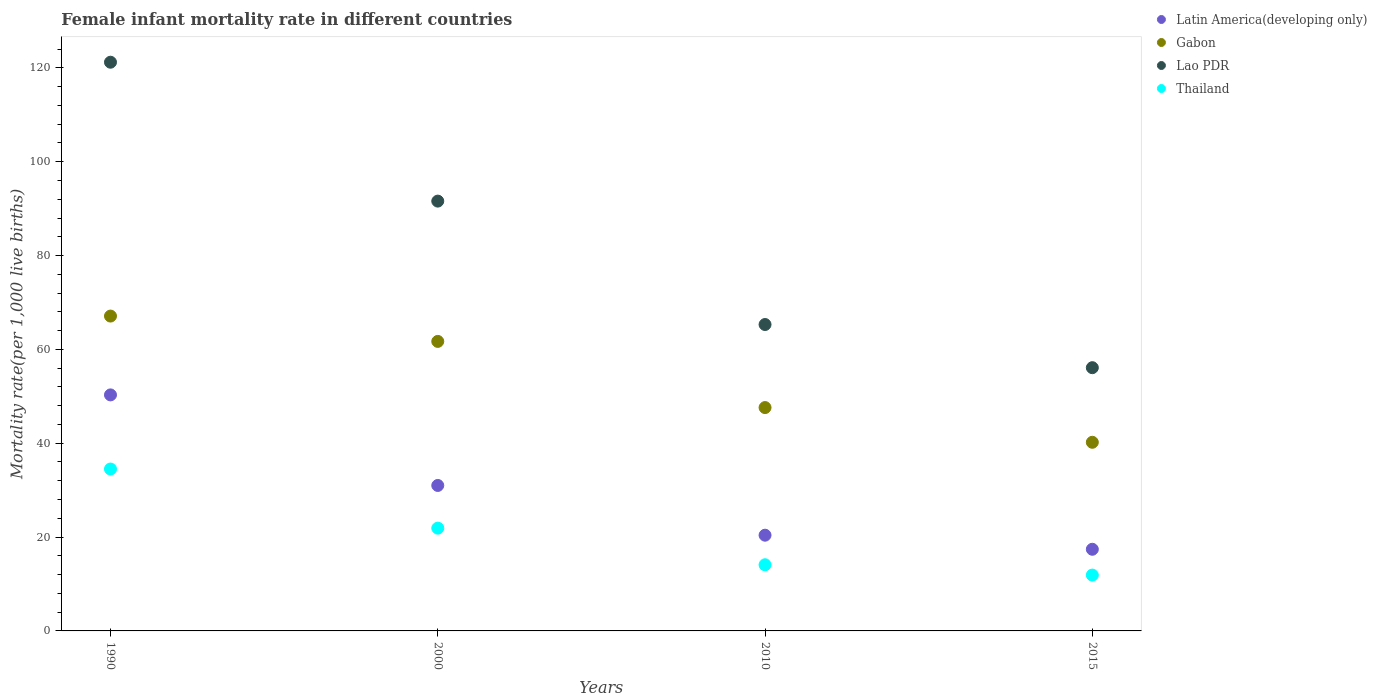How many different coloured dotlines are there?
Make the answer very short. 4. Is the number of dotlines equal to the number of legend labels?
Provide a succinct answer. Yes. Across all years, what is the maximum female infant mortality rate in Lao PDR?
Offer a very short reply. 121.2. Across all years, what is the minimum female infant mortality rate in Gabon?
Ensure brevity in your answer.  40.2. In which year was the female infant mortality rate in Latin America(developing only) maximum?
Ensure brevity in your answer.  1990. In which year was the female infant mortality rate in Lao PDR minimum?
Provide a succinct answer. 2015. What is the total female infant mortality rate in Gabon in the graph?
Make the answer very short. 216.6. What is the difference between the female infant mortality rate in Lao PDR in 2000 and that in 2015?
Your response must be concise. 35.5. What is the difference between the female infant mortality rate in Thailand in 2015 and the female infant mortality rate in Lao PDR in 1990?
Give a very brief answer. -109.3. What is the average female infant mortality rate in Thailand per year?
Give a very brief answer. 20.6. In the year 2010, what is the difference between the female infant mortality rate in Latin America(developing only) and female infant mortality rate in Thailand?
Offer a terse response. 6.3. What is the ratio of the female infant mortality rate in Latin America(developing only) in 2010 to that in 2015?
Offer a very short reply. 1.17. Is the female infant mortality rate in Lao PDR in 2000 less than that in 2010?
Ensure brevity in your answer.  No. Is the difference between the female infant mortality rate in Latin America(developing only) in 1990 and 2000 greater than the difference between the female infant mortality rate in Thailand in 1990 and 2000?
Ensure brevity in your answer.  Yes. What is the difference between the highest and the second highest female infant mortality rate in Thailand?
Keep it short and to the point. 12.6. What is the difference between the highest and the lowest female infant mortality rate in Thailand?
Offer a very short reply. 22.6. Is it the case that in every year, the sum of the female infant mortality rate in Gabon and female infant mortality rate in Latin America(developing only)  is greater than the female infant mortality rate in Thailand?
Your answer should be compact. Yes. Does the female infant mortality rate in Lao PDR monotonically increase over the years?
Give a very brief answer. No. Is the female infant mortality rate in Lao PDR strictly less than the female infant mortality rate in Gabon over the years?
Your answer should be compact. No. Are the values on the major ticks of Y-axis written in scientific E-notation?
Give a very brief answer. No. Does the graph contain grids?
Your answer should be very brief. No. Where does the legend appear in the graph?
Provide a short and direct response. Top right. How many legend labels are there?
Your answer should be compact. 4. What is the title of the graph?
Make the answer very short. Female infant mortality rate in different countries. What is the label or title of the Y-axis?
Your answer should be compact. Mortality rate(per 1,0 live births). What is the Mortality rate(per 1,000 live births) of Latin America(developing only) in 1990?
Keep it short and to the point. 50.3. What is the Mortality rate(per 1,000 live births) in Gabon in 1990?
Offer a very short reply. 67.1. What is the Mortality rate(per 1,000 live births) in Lao PDR in 1990?
Your response must be concise. 121.2. What is the Mortality rate(per 1,000 live births) of Thailand in 1990?
Your answer should be very brief. 34.5. What is the Mortality rate(per 1,000 live births) in Latin America(developing only) in 2000?
Your answer should be compact. 31. What is the Mortality rate(per 1,000 live births) of Gabon in 2000?
Keep it short and to the point. 61.7. What is the Mortality rate(per 1,000 live births) in Lao PDR in 2000?
Give a very brief answer. 91.6. What is the Mortality rate(per 1,000 live births) of Thailand in 2000?
Keep it short and to the point. 21.9. What is the Mortality rate(per 1,000 live births) in Latin America(developing only) in 2010?
Keep it short and to the point. 20.4. What is the Mortality rate(per 1,000 live births) in Gabon in 2010?
Ensure brevity in your answer.  47.6. What is the Mortality rate(per 1,000 live births) of Lao PDR in 2010?
Make the answer very short. 65.3. What is the Mortality rate(per 1,000 live births) of Gabon in 2015?
Your response must be concise. 40.2. What is the Mortality rate(per 1,000 live births) of Lao PDR in 2015?
Keep it short and to the point. 56.1. What is the Mortality rate(per 1,000 live births) in Thailand in 2015?
Offer a very short reply. 11.9. Across all years, what is the maximum Mortality rate(per 1,000 live births) in Latin America(developing only)?
Offer a very short reply. 50.3. Across all years, what is the maximum Mortality rate(per 1,000 live births) in Gabon?
Your response must be concise. 67.1. Across all years, what is the maximum Mortality rate(per 1,000 live births) of Lao PDR?
Your answer should be compact. 121.2. Across all years, what is the maximum Mortality rate(per 1,000 live births) in Thailand?
Provide a succinct answer. 34.5. Across all years, what is the minimum Mortality rate(per 1,000 live births) in Gabon?
Offer a very short reply. 40.2. Across all years, what is the minimum Mortality rate(per 1,000 live births) in Lao PDR?
Provide a succinct answer. 56.1. What is the total Mortality rate(per 1,000 live births) of Latin America(developing only) in the graph?
Ensure brevity in your answer.  119.1. What is the total Mortality rate(per 1,000 live births) in Gabon in the graph?
Give a very brief answer. 216.6. What is the total Mortality rate(per 1,000 live births) in Lao PDR in the graph?
Give a very brief answer. 334.2. What is the total Mortality rate(per 1,000 live births) of Thailand in the graph?
Your answer should be very brief. 82.4. What is the difference between the Mortality rate(per 1,000 live births) of Latin America(developing only) in 1990 and that in 2000?
Provide a short and direct response. 19.3. What is the difference between the Mortality rate(per 1,000 live births) in Lao PDR in 1990 and that in 2000?
Give a very brief answer. 29.6. What is the difference between the Mortality rate(per 1,000 live births) of Thailand in 1990 and that in 2000?
Offer a terse response. 12.6. What is the difference between the Mortality rate(per 1,000 live births) of Latin America(developing only) in 1990 and that in 2010?
Offer a terse response. 29.9. What is the difference between the Mortality rate(per 1,000 live births) in Lao PDR in 1990 and that in 2010?
Your answer should be compact. 55.9. What is the difference between the Mortality rate(per 1,000 live births) in Thailand in 1990 and that in 2010?
Offer a very short reply. 20.4. What is the difference between the Mortality rate(per 1,000 live births) in Latin America(developing only) in 1990 and that in 2015?
Keep it short and to the point. 32.9. What is the difference between the Mortality rate(per 1,000 live births) in Gabon in 1990 and that in 2015?
Ensure brevity in your answer.  26.9. What is the difference between the Mortality rate(per 1,000 live births) in Lao PDR in 1990 and that in 2015?
Provide a short and direct response. 65.1. What is the difference between the Mortality rate(per 1,000 live births) of Thailand in 1990 and that in 2015?
Your answer should be compact. 22.6. What is the difference between the Mortality rate(per 1,000 live births) of Latin America(developing only) in 2000 and that in 2010?
Provide a succinct answer. 10.6. What is the difference between the Mortality rate(per 1,000 live births) of Gabon in 2000 and that in 2010?
Your response must be concise. 14.1. What is the difference between the Mortality rate(per 1,000 live births) in Lao PDR in 2000 and that in 2010?
Your answer should be very brief. 26.3. What is the difference between the Mortality rate(per 1,000 live births) in Gabon in 2000 and that in 2015?
Your answer should be very brief. 21.5. What is the difference between the Mortality rate(per 1,000 live births) of Lao PDR in 2000 and that in 2015?
Ensure brevity in your answer.  35.5. What is the difference between the Mortality rate(per 1,000 live births) in Lao PDR in 2010 and that in 2015?
Provide a short and direct response. 9.2. What is the difference between the Mortality rate(per 1,000 live births) of Thailand in 2010 and that in 2015?
Offer a terse response. 2.2. What is the difference between the Mortality rate(per 1,000 live births) of Latin America(developing only) in 1990 and the Mortality rate(per 1,000 live births) of Gabon in 2000?
Offer a very short reply. -11.4. What is the difference between the Mortality rate(per 1,000 live births) in Latin America(developing only) in 1990 and the Mortality rate(per 1,000 live births) in Lao PDR in 2000?
Your answer should be very brief. -41.3. What is the difference between the Mortality rate(per 1,000 live births) in Latin America(developing only) in 1990 and the Mortality rate(per 1,000 live births) in Thailand in 2000?
Give a very brief answer. 28.4. What is the difference between the Mortality rate(per 1,000 live births) in Gabon in 1990 and the Mortality rate(per 1,000 live births) in Lao PDR in 2000?
Provide a short and direct response. -24.5. What is the difference between the Mortality rate(per 1,000 live births) in Gabon in 1990 and the Mortality rate(per 1,000 live births) in Thailand in 2000?
Make the answer very short. 45.2. What is the difference between the Mortality rate(per 1,000 live births) of Lao PDR in 1990 and the Mortality rate(per 1,000 live births) of Thailand in 2000?
Give a very brief answer. 99.3. What is the difference between the Mortality rate(per 1,000 live births) in Latin America(developing only) in 1990 and the Mortality rate(per 1,000 live births) in Gabon in 2010?
Your answer should be compact. 2.7. What is the difference between the Mortality rate(per 1,000 live births) in Latin America(developing only) in 1990 and the Mortality rate(per 1,000 live births) in Lao PDR in 2010?
Your response must be concise. -15. What is the difference between the Mortality rate(per 1,000 live births) of Latin America(developing only) in 1990 and the Mortality rate(per 1,000 live births) of Thailand in 2010?
Your response must be concise. 36.2. What is the difference between the Mortality rate(per 1,000 live births) in Gabon in 1990 and the Mortality rate(per 1,000 live births) in Lao PDR in 2010?
Provide a short and direct response. 1.8. What is the difference between the Mortality rate(per 1,000 live births) of Gabon in 1990 and the Mortality rate(per 1,000 live births) of Thailand in 2010?
Provide a succinct answer. 53. What is the difference between the Mortality rate(per 1,000 live births) in Lao PDR in 1990 and the Mortality rate(per 1,000 live births) in Thailand in 2010?
Give a very brief answer. 107.1. What is the difference between the Mortality rate(per 1,000 live births) of Latin America(developing only) in 1990 and the Mortality rate(per 1,000 live births) of Lao PDR in 2015?
Provide a short and direct response. -5.8. What is the difference between the Mortality rate(per 1,000 live births) of Latin America(developing only) in 1990 and the Mortality rate(per 1,000 live births) of Thailand in 2015?
Give a very brief answer. 38.4. What is the difference between the Mortality rate(per 1,000 live births) of Gabon in 1990 and the Mortality rate(per 1,000 live births) of Lao PDR in 2015?
Offer a very short reply. 11. What is the difference between the Mortality rate(per 1,000 live births) of Gabon in 1990 and the Mortality rate(per 1,000 live births) of Thailand in 2015?
Provide a succinct answer. 55.2. What is the difference between the Mortality rate(per 1,000 live births) of Lao PDR in 1990 and the Mortality rate(per 1,000 live births) of Thailand in 2015?
Offer a terse response. 109.3. What is the difference between the Mortality rate(per 1,000 live births) in Latin America(developing only) in 2000 and the Mortality rate(per 1,000 live births) in Gabon in 2010?
Offer a very short reply. -16.6. What is the difference between the Mortality rate(per 1,000 live births) of Latin America(developing only) in 2000 and the Mortality rate(per 1,000 live births) of Lao PDR in 2010?
Offer a very short reply. -34.3. What is the difference between the Mortality rate(per 1,000 live births) of Gabon in 2000 and the Mortality rate(per 1,000 live births) of Thailand in 2010?
Provide a succinct answer. 47.6. What is the difference between the Mortality rate(per 1,000 live births) of Lao PDR in 2000 and the Mortality rate(per 1,000 live births) of Thailand in 2010?
Give a very brief answer. 77.5. What is the difference between the Mortality rate(per 1,000 live births) in Latin America(developing only) in 2000 and the Mortality rate(per 1,000 live births) in Lao PDR in 2015?
Offer a terse response. -25.1. What is the difference between the Mortality rate(per 1,000 live births) in Gabon in 2000 and the Mortality rate(per 1,000 live births) in Thailand in 2015?
Your response must be concise. 49.8. What is the difference between the Mortality rate(per 1,000 live births) in Lao PDR in 2000 and the Mortality rate(per 1,000 live births) in Thailand in 2015?
Make the answer very short. 79.7. What is the difference between the Mortality rate(per 1,000 live births) of Latin America(developing only) in 2010 and the Mortality rate(per 1,000 live births) of Gabon in 2015?
Your answer should be compact. -19.8. What is the difference between the Mortality rate(per 1,000 live births) of Latin America(developing only) in 2010 and the Mortality rate(per 1,000 live births) of Lao PDR in 2015?
Your answer should be very brief. -35.7. What is the difference between the Mortality rate(per 1,000 live births) of Latin America(developing only) in 2010 and the Mortality rate(per 1,000 live births) of Thailand in 2015?
Offer a very short reply. 8.5. What is the difference between the Mortality rate(per 1,000 live births) of Gabon in 2010 and the Mortality rate(per 1,000 live births) of Lao PDR in 2015?
Make the answer very short. -8.5. What is the difference between the Mortality rate(per 1,000 live births) of Gabon in 2010 and the Mortality rate(per 1,000 live births) of Thailand in 2015?
Provide a short and direct response. 35.7. What is the difference between the Mortality rate(per 1,000 live births) of Lao PDR in 2010 and the Mortality rate(per 1,000 live births) of Thailand in 2015?
Provide a succinct answer. 53.4. What is the average Mortality rate(per 1,000 live births) of Latin America(developing only) per year?
Ensure brevity in your answer.  29.77. What is the average Mortality rate(per 1,000 live births) in Gabon per year?
Offer a terse response. 54.15. What is the average Mortality rate(per 1,000 live births) of Lao PDR per year?
Your answer should be compact. 83.55. What is the average Mortality rate(per 1,000 live births) in Thailand per year?
Ensure brevity in your answer.  20.6. In the year 1990, what is the difference between the Mortality rate(per 1,000 live births) in Latin America(developing only) and Mortality rate(per 1,000 live births) in Gabon?
Your answer should be very brief. -16.8. In the year 1990, what is the difference between the Mortality rate(per 1,000 live births) in Latin America(developing only) and Mortality rate(per 1,000 live births) in Lao PDR?
Offer a very short reply. -70.9. In the year 1990, what is the difference between the Mortality rate(per 1,000 live births) of Latin America(developing only) and Mortality rate(per 1,000 live births) of Thailand?
Keep it short and to the point. 15.8. In the year 1990, what is the difference between the Mortality rate(per 1,000 live births) in Gabon and Mortality rate(per 1,000 live births) in Lao PDR?
Make the answer very short. -54.1. In the year 1990, what is the difference between the Mortality rate(per 1,000 live births) in Gabon and Mortality rate(per 1,000 live births) in Thailand?
Your response must be concise. 32.6. In the year 1990, what is the difference between the Mortality rate(per 1,000 live births) in Lao PDR and Mortality rate(per 1,000 live births) in Thailand?
Offer a terse response. 86.7. In the year 2000, what is the difference between the Mortality rate(per 1,000 live births) of Latin America(developing only) and Mortality rate(per 1,000 live births) of Gabon?
Give a very brief answer. -30.7. In the year 2000, what is the difference between the Mortality rate(per 1,000 live births) in Latin America(developing only) and Mortality rate(per 1,000 live births) in Lao PDR?
Keep it short and to the point. -60.6. In the year 2000, what is the difference between the Mortality rate(per 1,000 live births) of Gabon and Mortality rate(per 1,000 live births) of Lao PDR?
Give a very brief answer. -29.9. In the year 2000, what is the difference between the Mortality rate(per 1,000 live births) of Gabon and Mortality rate(per 1,000 live births) of Thailand?
Offer a very short reply. 39.8. In the year 2000, what is the difference between the Mortality rate(per 1,000 live births) in Lao PDR and Mortality rate(per 1,000 live births) in Thailand?
Offer a terse response. 69.7. In the year 2010, what is the difference between the Mortality rate(per 1,000 live births) in Latin America(developing only) and Mortality rate(per 1,000 live births) in Gabon?
Ensure brevity in your answer.  -27.2. In the year 2010, what is the difference between the Mortality rate(per 1,000 live births) in Latin America(developing only) and Mortality rate(per 1,000 live births) in Lao PDR?
Your answer should be very brief. -44.9. In the year 2010, what is the difference between the Mortality rate(per 1,000 live births) of Gabon and Mortality rate(per 1,000 live births) of Lao PDR?
Ensure brevity in your answer.  -17.7. In the year 2010, what is the difference between the Mortality rate(per 1,000 live births) of Gabon and Mortality rate(per 1,000 live births) of Thailand?
Provide a succinct answer. 33.5. In the year 2010, what is the difference between the Mortality rate(per 1,000 live births) of Lao PDR and Mortality rate(per 1,000 live births) of Thailand?
Ensure brevity in your answer.  51.2. In the year 2015, what is the difference between the Mortality rate(per 1,000 live births) of Latin America(developing only) and Mortality rate(per 1,000 live births) of Gabon?
Give a very brief answer. -22.8. In the year 2015, what is the difference between the Mortality rate(per 1,000 live births) in Latin America(developing only) and Mortality rate(per 1,000 live births) in Lao PDR?
Offer a very short reply. -38.7. In the year 2015, what is the difference between the Mortality rate(per 1,000 live births) in Gabon and Mortality rate(per 1,000 live births) in Lao PDR?
Your answer should be compact. -15.9. In the year 2015, what is the difference between the Mortality rate(per 1,000 live births) in Gabon and Mortality rate(per 1,000 live births) in Thailand?
Your response must be concise. 28.3. In the year 2015, what is the difference between the Mortality rate(per 1,000 live births) in Lao PDR and Mortality rate(per 1,000 live births) in Thailand?
Your answer should be very brief. 44.2. What is the ratio of the Mortality rate(per 1,000 live births) of Latin America(developing only) in 1990 to that in 2000?
Your answer should be compact. 1.62. What is the ratio of the Mortality rate(per 1,000 live births) of Gabon in 1990 to that in 2000?
Provide a short and direct response. 1.09. What is the ratio of the Mortality rate(per 1,000 live births) in Lao PDR in 1990 to that in 2000?
Offer a terse response. 1.32. What is the ratio of the Mortality rate(per 1,000 live births) of Thailand in 1990 to that in 2000?
Provide a short and direct response. 1.58. What is the ratio of the Mortality rate(per 1,000 live births) of Latin America(developing only) in 1990 to that in 2010?
Your response must be concise. 2.47. What is the ratio of the Mortality rate(per 1,000 live births) of Gabon in 1990 to that in 2010?
Provide a succinct answer. 1.41. What is the ratio of the Mortality rate(per 1,000 live births) in Lao PDR in 1990 to that in 2010?
Provide a succinct answer. 1.86. What is the ratio of the Mortality rate(per 1,000 live births) of Thailand in 1990 to that in 2010?
Provide a short and direct response. 2.45. What is the ratio of the Mortality rate(per 1,000 live births) in Latin America(developing only) in 1990 to that in 2015?
Your answer should be compact. 2.89. What is the ratio of the Mortality rate(per 1,000 live births) of Gabon in 1990 to that in 2015?
Your response must be concise. 1.67. What is the ratio of the Mortality rate(per 1,000 live births) in Lao PDR in 1990 to that in 2015?
Make the answer very short. 2.16. What is the ratio of the Mortality rate(per 1,000 live births) in Thailand in 1990 to that in 2015?
Your response must be concise. 2.9. What is the ratio of the Mortality rate(per 1,000 live births) of Latin America(developing only) in 2000 to that in 2010?
Ensure brevity in your answer.  1.52. What is the ratio of the Mortality rate(per 1,000 live births) of Gabon in 2000 to that in 2010?
Your answer should be compact. 1.3. What is the ratio of the Mortality rate(per 1,000 live births) in Lao PDR in 2000 to that in 2010?
Your response must be concise. 1.4. What is the ratio of the Mortality rate(per 1,000 live births) of Thailand in 2000 to that in 2010?
Give a very brief answer. 1.55. What is the ratio of the Mortality rate(per 1,000 live births) in Latin America(developing only) in 2000 to that in 2015?
Make the answer very short. 1.78. What is the ratio of the Mortality rate(per 1,000 live births) in Gabon in 2000 to that in 2015?
Offer a very short reply. 1.53. What is the ratio of the Mortality rate(per 1,000 live births) of Lao PDR in 2000 to that in 2015?
Give a very brief answer. 1.63. What is the ratio of the Mortality rate(per 1,000 live births) of Thailand in 2000 to that in 2015?
Your answer should be very brief. 1.84. What is the ratio of the Mortality rate(per 1,000 live births) of Latin America(developing only) in 2010 to that in 2015?
Ensure brevity in your answer.  1.17. What is the ratio of the Mortality rate(per 1,000 live births) in Gabon in 2010 to that in 2015?
Make the answer very short. 1.18. What is the ratio of the Mortality rate(per 1,000 live births) in Lao PDR in 2010 to that in 2015?
Offer a very short reply. 1.16. What is the ratio of the Mortality rate(per 1,000 live births) in Thailand in 2010 to that in 2015?
Make the answer very short. 1.18. What is the difference between the highest and the second highest Mortality rate(per 1,000 live births) of Latin America(developing only)?
Give a very brief answer. 19.3. What is the difference between the highest and the second highest Mortality rate(per 1,000 live births) of Gabon?
Keep it short and to the point. 5.4. What is the difference between the highest and the second highest Mortality rate(per 1,000 live births) of Lao PDR?
Make the answer very short. 29.6. What is the difference between the highest and the lowest Mortality rate(per 1,000 live births) of Latin America(developing only)?
Keep it short and to the point. 32.9. What is the difference between the highest and the lowest Mortality rate(per 1,000 live births) of Gabon?
Your answer should be compact. 26.9. What is the difference between the highest and the lowest Mortality rate(per 1,000 live births) in Lao PDR?
Your answer should be compact. 65.1. What is the difference between the highest and the lowest Mortality rate(per 1,000 live births) of Thailand?
Give a very brief answer. 22.6. 